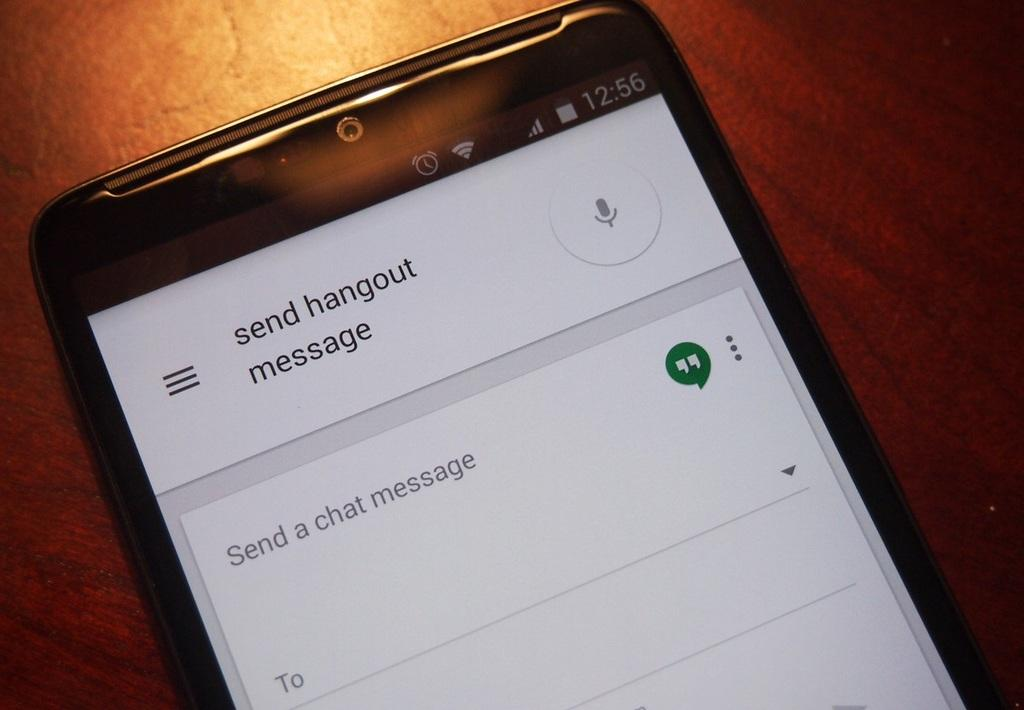<image>
Present a compact description of the photo's key features. black phone with screen on send hangout message 